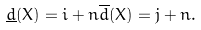<formula> <loc_0><loc_0><loc_500><loc_500>\underline { d } ( X ) = i + n \overline { d } ( X ) = j + n .</formula> 